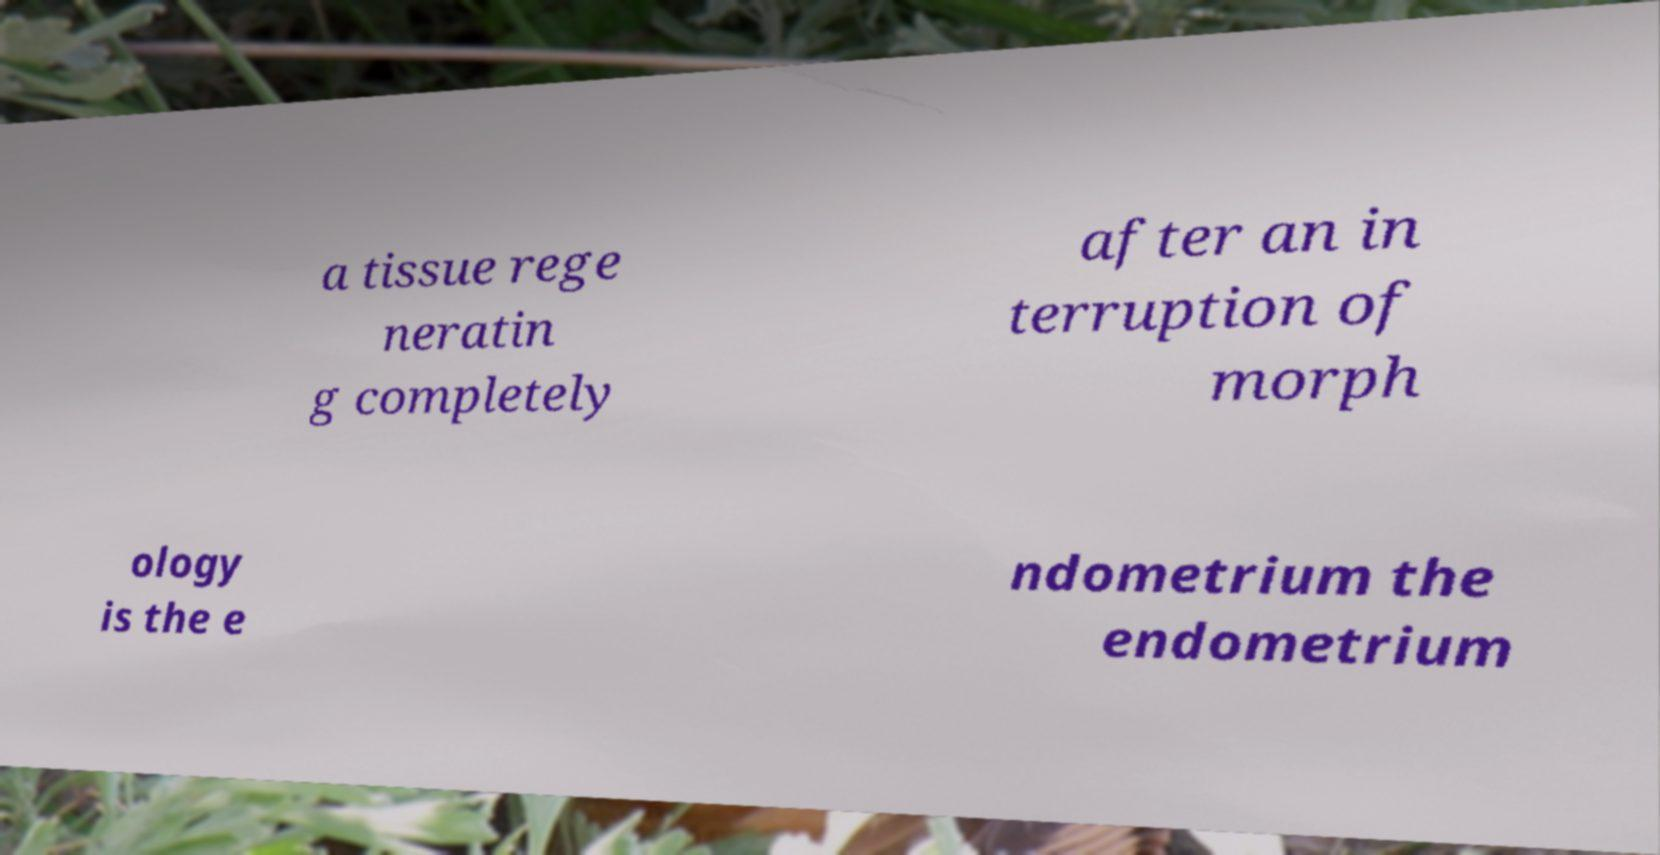What messages or text are displayed in this image? I need them in a readable, typed format. a tissue rege neratin g completely after an in terruption of morph ology is the e ndometrium the endometrium 